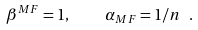<formula> <loc_0><loc_0><loc_500><loc_500>\beta ^ { M F } = 1 , \quad \alpha _ { M F } = 1 / n \ .</formula> 